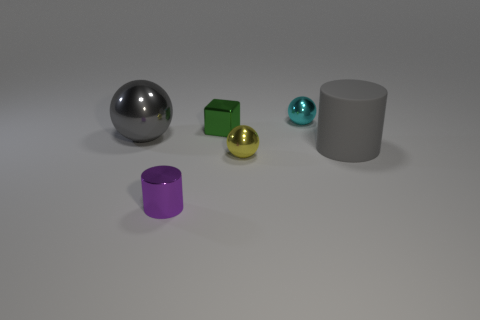Are there any other things that are the same material as the large cylinder?
Offer a very short reply. No. What number of objects are tiny balls that are in front of the green metallic thing or yellow metallic objects?
Offer a terse response. 1. Does the rubber object have the same size as the sphere on the left side of the metallic cube?
Your answer should be compact. Yes. What number of tiny objects are either cyan spheres or purple things?
Your response must be concise. 2. What shape is the green shiny object?
Your response must be concise. Cube. What is the size of the object that is the same color as the matte cylinder?
Your answer should be very brief. Large. Are there any purple objects that have the same material as the tiny cylinder?
Your answer should be compact. No. Are there more metal objects than green matte balls?
Give a very brief answer. Yes. Is the large gray cylinder made of the same material as the small block?
Your response must be concise. No. How many shiny objects are big cyan objects or tiny yellow spheres?
Provide a short and direct response. 1. 